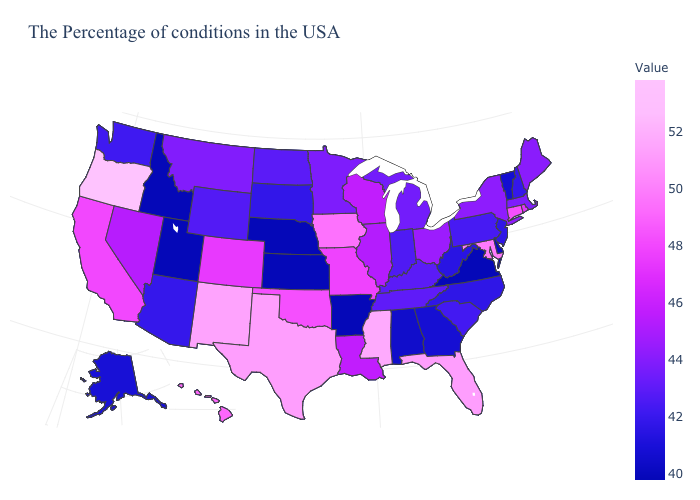Which states have the highest value in the USA?
Keep it brief. Oregon. Which states have the lowest value in the Northeast?
Be succinct. Vermont. Is the legend a continuous bar?
Write a very short answer. Yes. Does Hawaii have a lower value than Louisiana?
Concise answer only. No. Among the states that border Kansas , which have the highest value?
Answer briefly. Oklahoma. 